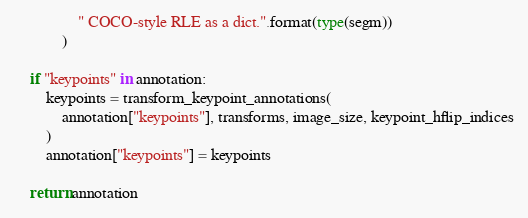Convert code to text. <code><loc_0><loc_0><loc_500><loc_500><_Python_>                " COCO-style RLE as a dict.".format(type(segm))
            )

    if "keypoints" in annotation:
        keypoints = transform_keypoint_annotations(
            annotation["keypoints"], transforms, image_size, keypoint_hflip_indices
        )
        annotation["keypoints"] = keypoints

    return annotation

</code> 